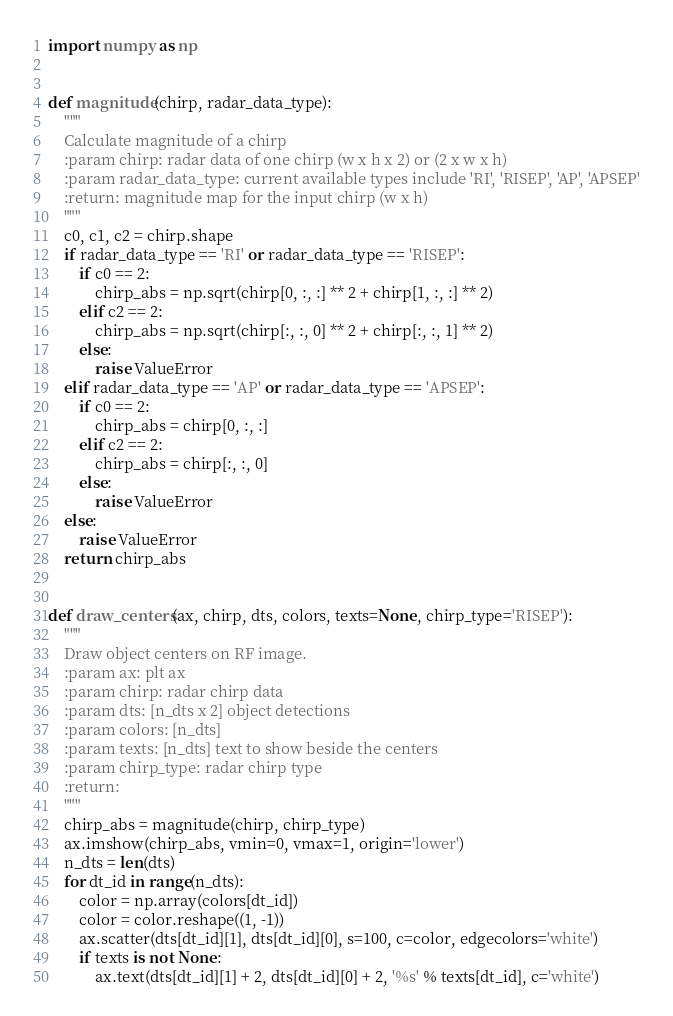<code> <loc_0><loc_0><loc_500><loc_500><_Python_>import numpy as np


def magnitude(chirp, radar_data_type):
    """
    Calculate magnitude of a chirp
    :param chirp: radar data of one chirp (w x h x 2) or (2 x w x h)
    :param radar_data_type: current available types include 'RI', 'RISEP', 'AP', 'APSEP'
    :return: magnitude map for the input chirp (w x h)
    """
    c0, c1, c2 = chirp.shape
    if radar_data_type == 'RI' or radar_data_type == 'RISEP':
        if c0 == 2:
            chirp_abs = np.sqrt(chirp[0, :, :] ** 2 + chirp[1, :, :] ** 2)
        elif c2 == 2:
            chirp_abs = np.sqrt(chirp[:, :, 0] ** 2 + chirp[:, :, 1] ** 2)
        else:
            raise ValueError
    elif radar_data_type == 'AP' or radar_data_type == 'APSEP':
        if c0 == 2:
            chirp_abs = chirp[0, :, :]
        elif c2 == 2:
            chirp_abs = chirp[:, :, 0]
        else:
            raise ValueError
    else:
        raise ValueError
    return chirp_abs


def draw_centers(ax, chirp, dts, colors, texts=None, chirp_type='RISEP'):
    """
    Draw object centers on RF image.
    :param ax: plt ax
    :param chirp: radar chirp data
    :param dts: [n_dts x 2] object detections
    :param colors: [n_dts]
    :param texts: [n_dts] text to show beside the centers
    :param chirp_type: radar chirp type
    :return:
    """
    chirp_abs = magnitude(chirp, chirp_type)
    ax.imshow(chirp_abs, vmin=0, vmax=1, origin='lower')
    n_dts = len(dts)
    for dt_id in range(n_dts):
        color = np.array(colors[dt_id])
        color = color.reshape((1, -1))
        ax.scatter(dts[dt_id][1], dts[dt_id][0], s=100, c=color, edgecolors='white')
        if texts is not None:
            ax.text(dts[dt_id][1] + 2, dts[dt_id][0] + 2, '%s' % texts[dt_id], c='white')
</code> 